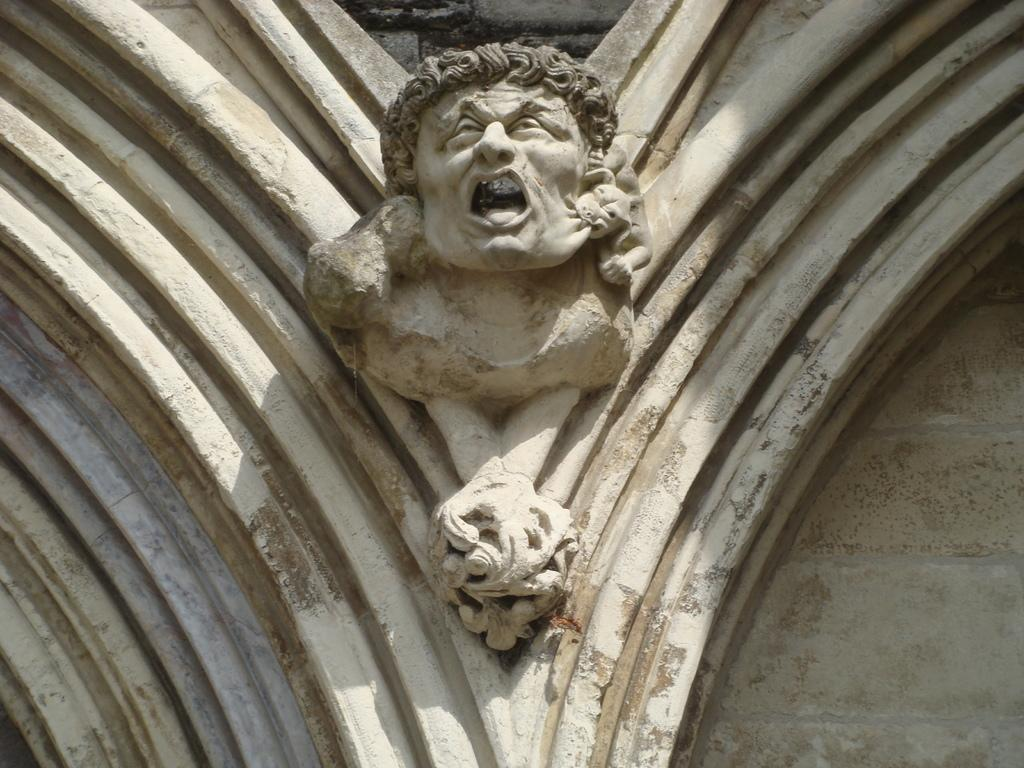What is on the wall in the image? There is a sculpture on the wall in the image. What type of pain is the sculpture experiencing in the image? The sculpture is not a living being and therefore cannot experience pain. Additionally, there is no indication of pain in the image. 